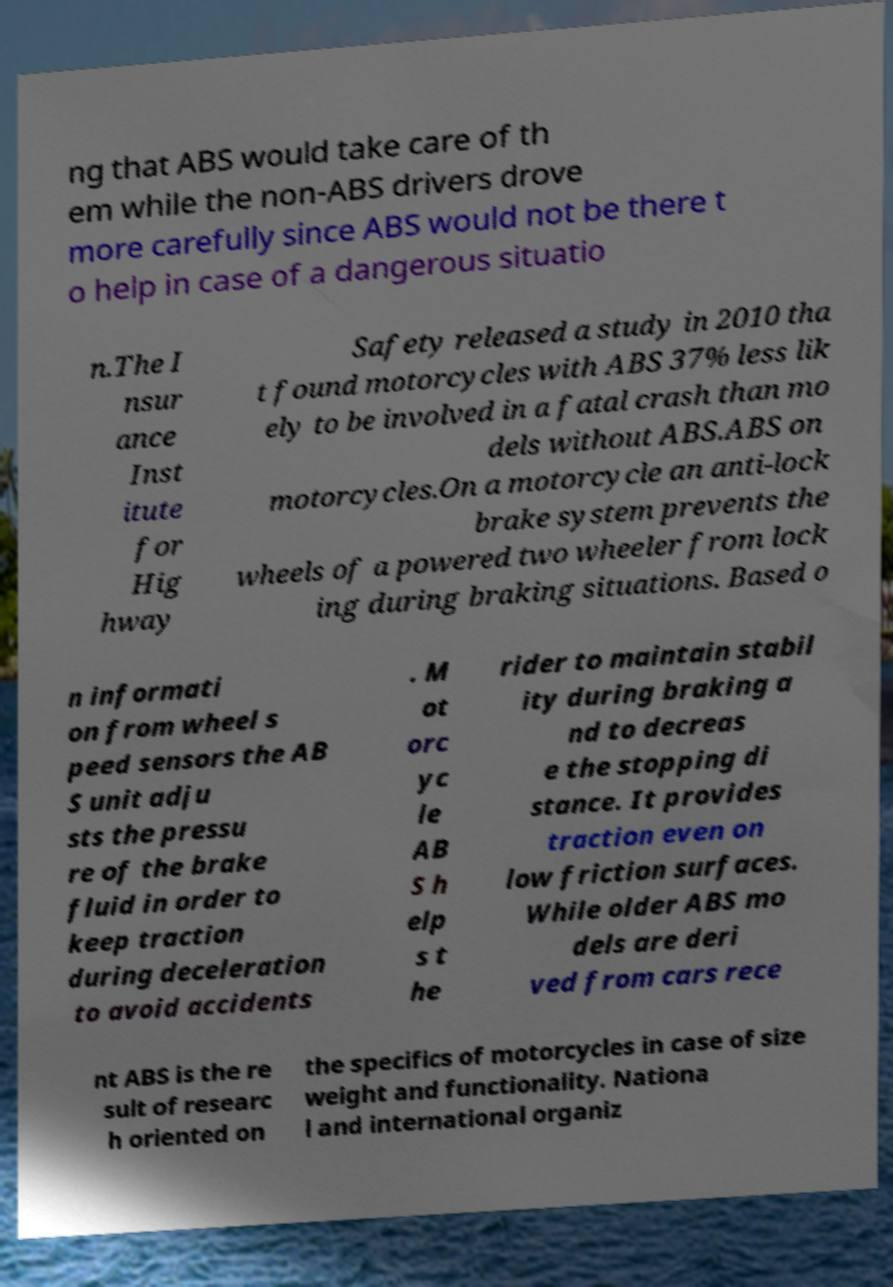Could you assist in decoding the text presented in this image and type it out clearly? ng that ABS would take care of th em while the non-ABS drivers drove more carefully since ABS would not be there t o help in case of a dangerous situatio n.The I nsur ance Inst itute for Hig hway Safety released a study in 2010 tha t found motorcycles with ABS 37% less lik ely to be involved in a fatal crash than mo dels without ABS.ABS on motorcycles.On a motorcycle an anti-lock brake system prevents the wheels of a powered two wheeler from lock ing during braking situations. Based o n informati on from wheel s peed sensors the AB S unit adju sts the pressu re of the brake fluid in order to keep traction during deceleration to avoid accidents . M ot orc yc le AB S h elp s t he rider to maintain stabil ity during braking a nd to decreas e the stopping di stance. It provides traction even on low friction surfaces. While older ABS mo dels are deri ved from cars rece nt ABS is the re sult of researc h oriented on the specifics of motorcycles in case of size weight and functionality. Nationa l and international organiz 